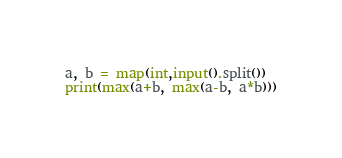Convert code to text. <code><loc_0><loc_0><loc_500><loc_500><_Python_>a, b = map(int,input().split())
print(max(a+b, max(a-b, a*b)))</code> 